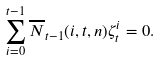<formula> <loc_0><loc_0><loc_500><loc_500>\sum _ { i = 0 } ^ { t - 1 } \overline { N } _ { t - 1 } ( i , t , n ) \zeta _ { t } ^ { i } = 0 .</formula> 